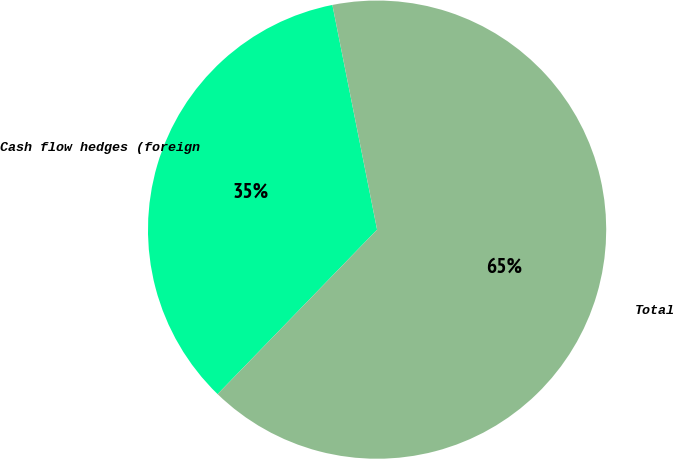<chart> <loc_0><loc_0><loc_500><loc_500><pie_chart><fcel>Cash flow hedges (foreign<fcel>Total<nl><fcel>34.62%<fcel>65.38%<nl></chart> 